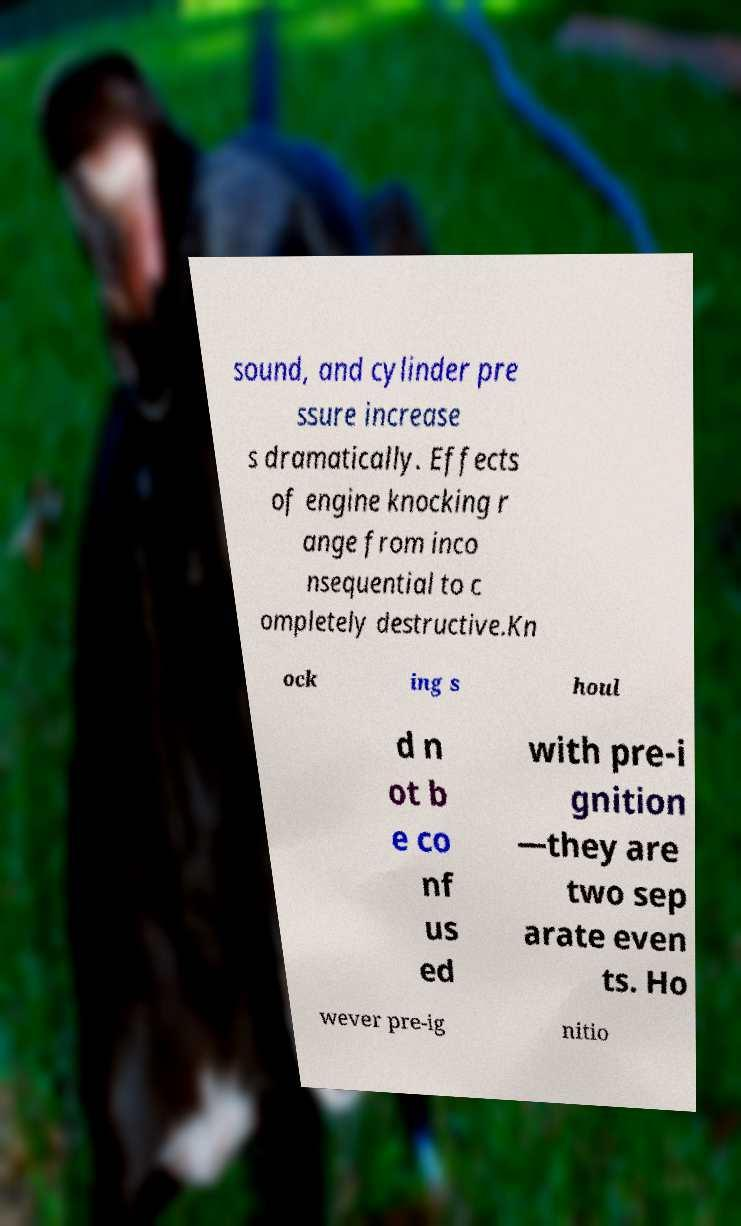I need the written content from this picture converted into text. Can you do that? sound, and cylinder pre ssure increase s dramatically. Effects of engine knocking r ange from inco nsequential to c ompletely destructive.Kn ock ing s houl d n ot b e co nf us ed with pre-i gnition —they are two sep arate even ts. Ho wever pre-ig nitio 